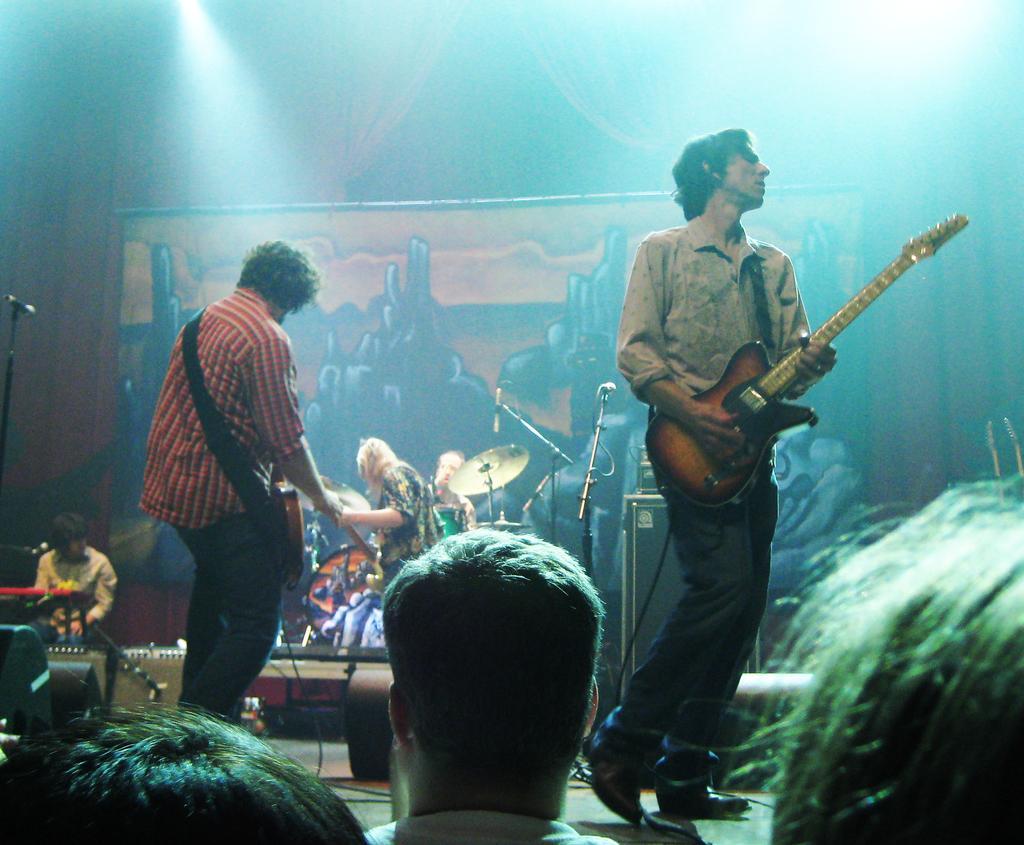Can you describe this image briefly? In this image, in the right side there is a man standing and he is holding a music instrument which is in yellow color, in the left side there is a man standing and he is holding a yellow color object, in the background there are some microphones and music instruments, there are some people standing. 